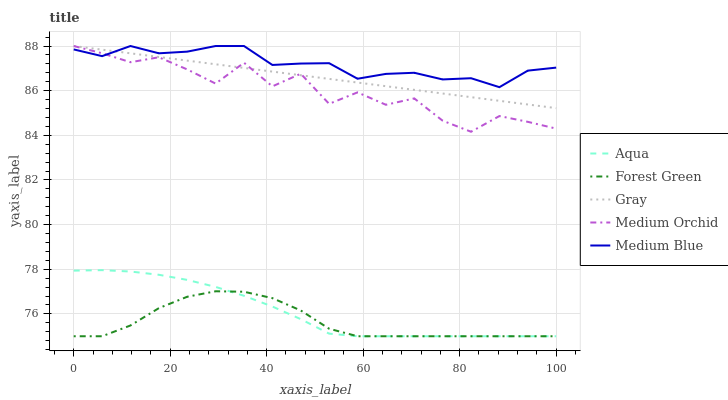Does Medium Orchid have the minimum area under the curve?
Answer yes or no. No. Does Medium Orchid have the maximum area under the curve?
Answer yes or no. No. Is Forest Green the smoothest?
Answer yes or no. No. Is Forest Green the roughest?
Answer yes or no. No. Does Medium Orchid have the lowest value?
Answer yes or no. No. Does Forest Green have the highest value?
Answer yes or no. No. Is Aqua less than Gray?
Answer yes or no. Yes. Is Gray greater than Aqua?
Answer yes or no. Yes. Does Aqua intersect Gray?
Answer yes or no. No. 